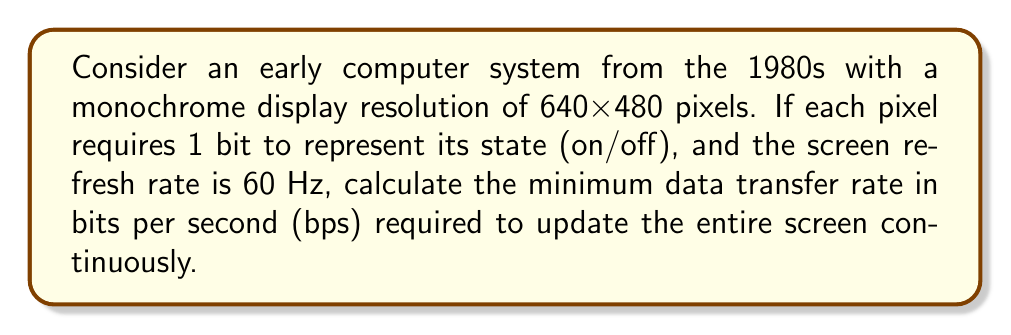What is the answer to this math problem? To solve this problem, we'll follow these steps:

1. Calculate the total number of pixels:
   $$ \text{Total pixels} = 640 \times 480 = 307,200 \text{ pixels} $$

2. Determine the number of bits needed to represent the entire screen:
   $$ \text{Bits per screen} = 307,200 \text{ pixels} \times 1 \text{ bit/pixel} = 307,200 \text{ bits} $$

3. Calculate the number of bits that need to be transferred per second:
   $$ \text{Bits per second} = 307,200 \text{ bits/screen} \times 60 \text{ screens/second} $$
   $$ \text{Bits per second} = 18,432,000 \text{ bps} $$

4. Convert to a more readable format:
   $$ 18,432,000 \text{ bps} = 18.432 \text{ Mbps} $$

Therefore, the minimum data transfer rate required to update the entire screen continuously is 18.432 Mbps.
Answer: 18.432 Mbps 